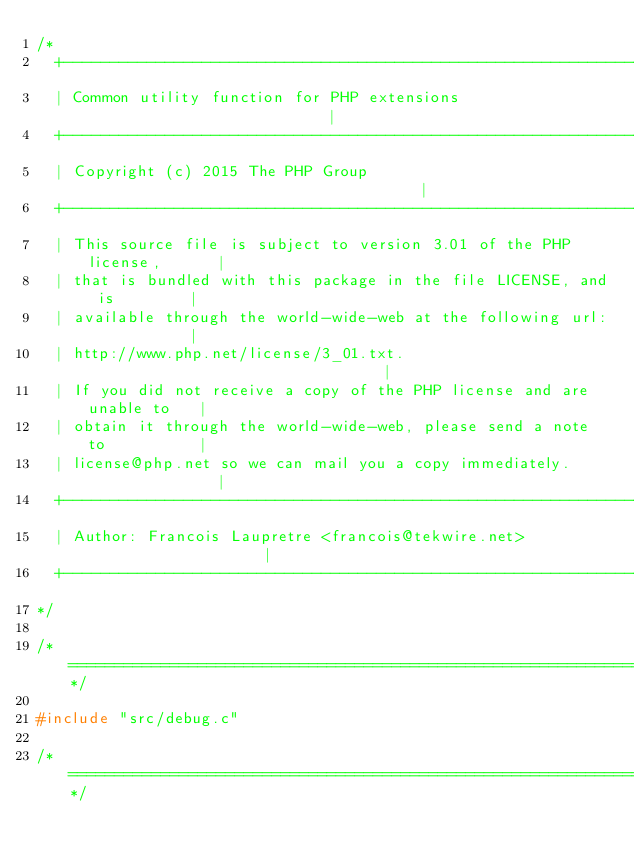<code> <loc_0><loc_0><loc_500><loc_500><_C_>/*
  +----------------------------------------------------------------------+
  | Common utility function for PHP extensions                           |
  +----------------------------------------------------------------------+
  | Copyright (c) 2015 The PHP Group                                     |
  +----------------------------------------------------------------------+
  | This source file is subject to version 3.01 of the PHP license,      |
  | that is bundled with this package in the file LICENSE, and is        |
  | available through the world-wide-web at the following url:           |
  | http://www.php.net/license/3_01.txt.                                 |
  | If you did not receive a copy of the PHP license and are unable to   |
  | obtain it through the world-wide-web, please send a note to          |
  | license@php.net so we can mail you a copy immediately.               |
  +----------------------------------------------------------------------+
  | Author: Francois Laupretre <francois@tekwire.net>                    |
  +----------------------------------------------------------------------+
*/

/*============================================================================*/

#include "src/debug.c"

/*============================================================================*/
</code> 